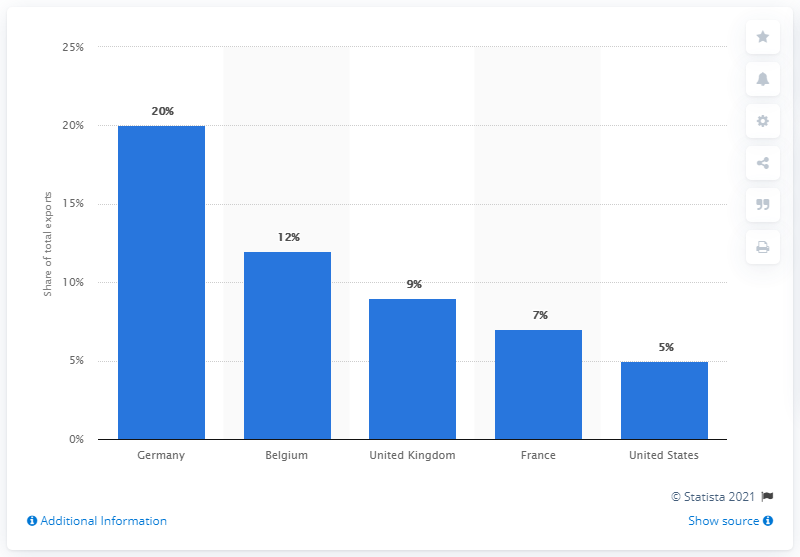Highlight a few significant elements in this photo. In 2019, Germany accounted for a significant portion of all exports. According to the Netherlands in 2019, Germany was the most important export partner. 